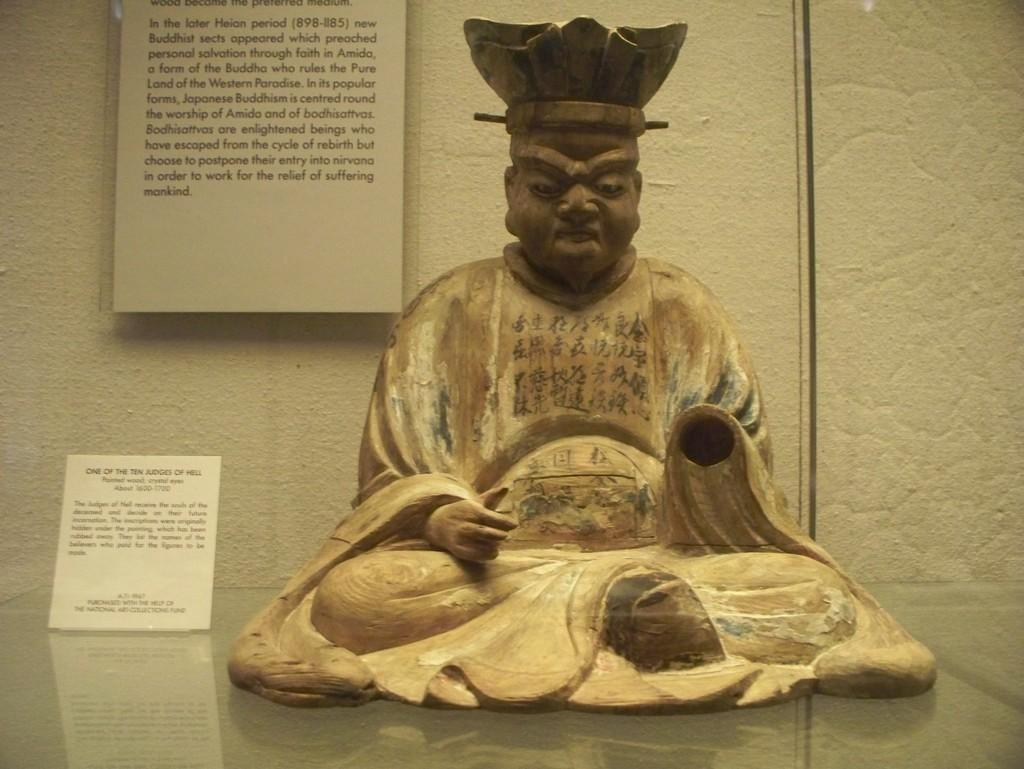What is the main subject in the center of the image? There is a sculpture in the center of the image. What can be seen on the left side of the image? There are posters on the left side of the image. What type of nose can be seen on the sculpture in the image? There is no nose visible on the sculpture in the image. Can you tell me how many cars are parked on the road in the image? There is no road or cars present in the image; it features a sculpture and posters. 